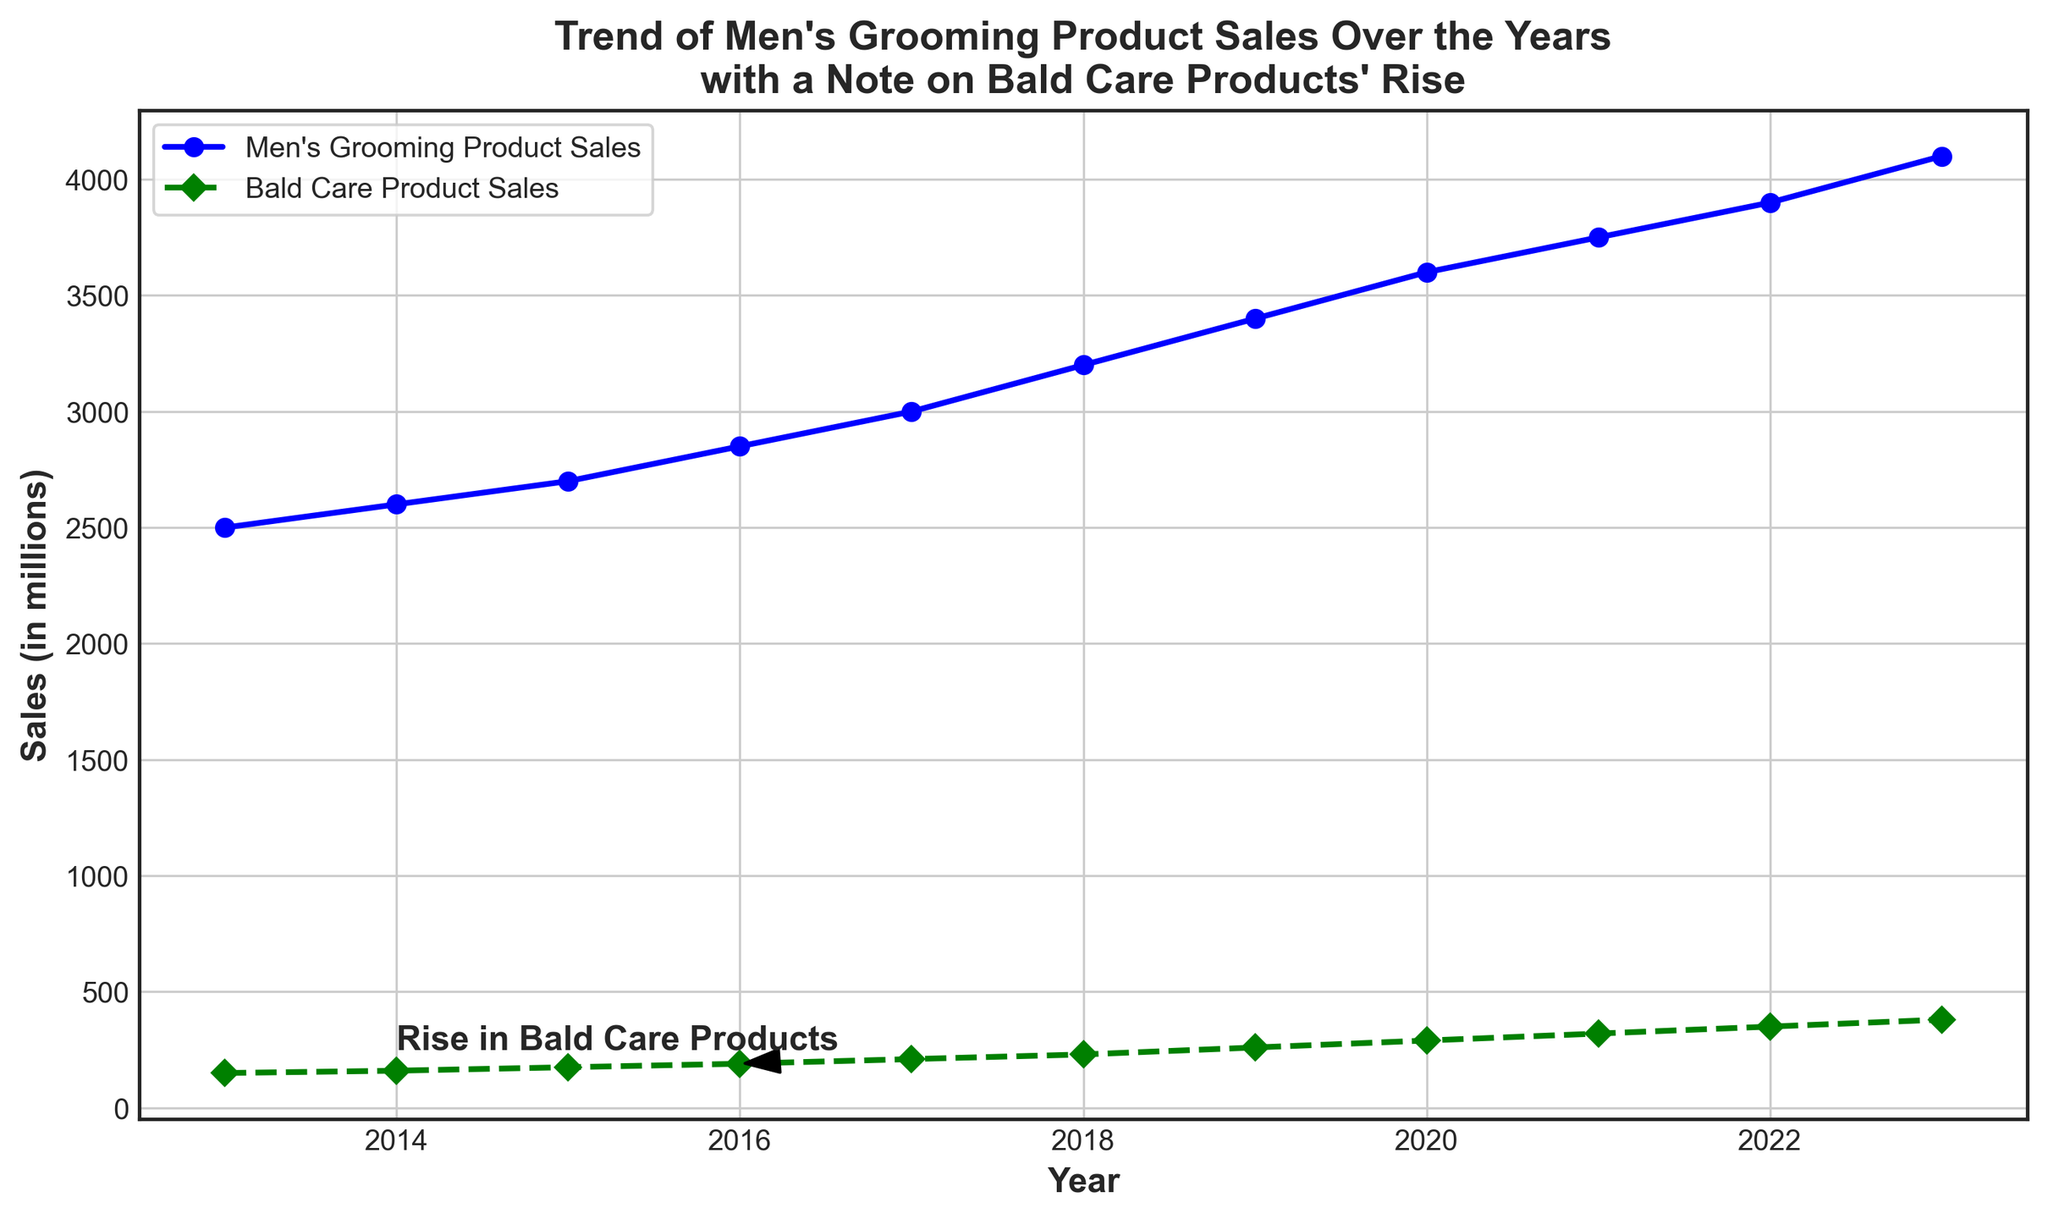What trend is observed in the sales of Men's Grooming Products from 2013 to 2023? The line plot shows that the sales of Men's Grooming Products steadily increase each year from 2500 million in 2013 to 4100 million in 2023.
Answer: Steady increase Which year marked the start of a noticeable rise in Bald Care Product Sales? The annotation in the plot highlights that around 2016 there was a noticeable rise in Bald Care Product Sales, with values increasing more sharply from that point.
Answer: 2016 By how much did Bald Care Product Sales increase from 2013 to 2023? In 2013, Bald Care Product Sales were 150 million, and by 2023 they rose to 380 million. The increase is 380 - 150 = 230 million.
Answer: 230 million Compare the growth rates of Men's Grooming Product Sales and Bald Care Product Sales between 2015 and 2020. From 2015 to 2020, Men's Grooming Product Sales increased from 2700 million to 3600 million, which is an increase of 900 million. Bald Care Product Sales increased from 175 million to 290 million, with an increase of 115 million. We need to calculate the percentage increase for both: Grooming = (900/2700) * 100 = 33.33%, Bald Care (115/175) * 100 = 65.71%.
Answer: Bald Care grew faster What is the difference in sales between Men's Grooming Products and Bald Care Products in 2021? In 2021, Men's Grooming Product Sales were 3750 million and Bald Care Product Sales were 320 million. The difference is 3750 - 320 = 3430 million.
Answer: 3430 million What is the ratio of Bald Care Product Sales to Men's Grooming Product Sales in 2023? In 2023, Bald Care Product Sales were 380 million and Men's Grooming Product Sales were 4100 million. The ratio is 380 / 4100 ≈ 0.0927.
Answer: 0.0927 Which product category saw a higher absolute increase in sales from 2019 to 2022? From 2019 to 2022, Men's Grooming Product Sales increased from 3400 million to 3900 million, an increase of 500 million. Bald Care Product Sales increased from 260 million to 350 million, an increase of 90 million.
Answer: Men's Grooming What is the average annual increase in Bald Care Product Sales from 2013 to 2023? Bald Care Product Sales in 2023 = 380 million, and in 2013 = 150 million. Total increase over 10 years = 380 - 150 = 230 million. The average annual increase = 230 / 10 = 23 million per year.
Answer: 23 million per year What can be inferred from the visual annotation on the chart? The annotation notes a "Rise in Bald Care Products" around the year 2016, indicating this period marked a significant increase in their sales, highlighted by an arrow pointing to the data point in 2016.
Answer: Significant increase in 2016 Which product category had a higher sales growth percentage between 2017 and 2021? From 2017 to 2021, Men's Grooming Product Sales increased from 3000 million to 3750 million (growth = (3750-3000)/3000 * 100 = 25%). Bald Care Product Sales increased from 210 million to 320 million (growth = (320-210)/210 * 100 ≈ 52.38%).
Answer: Bald Care Products 